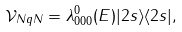<formula> <loc_0><loc_0><loc_500><loc_500>\mathcal { V } _ { N q N } = \lambda ^ { 0 } _ { 0 0 0 } ( E ) | 2 s \rangle \langle 2 s | ,</formula> 